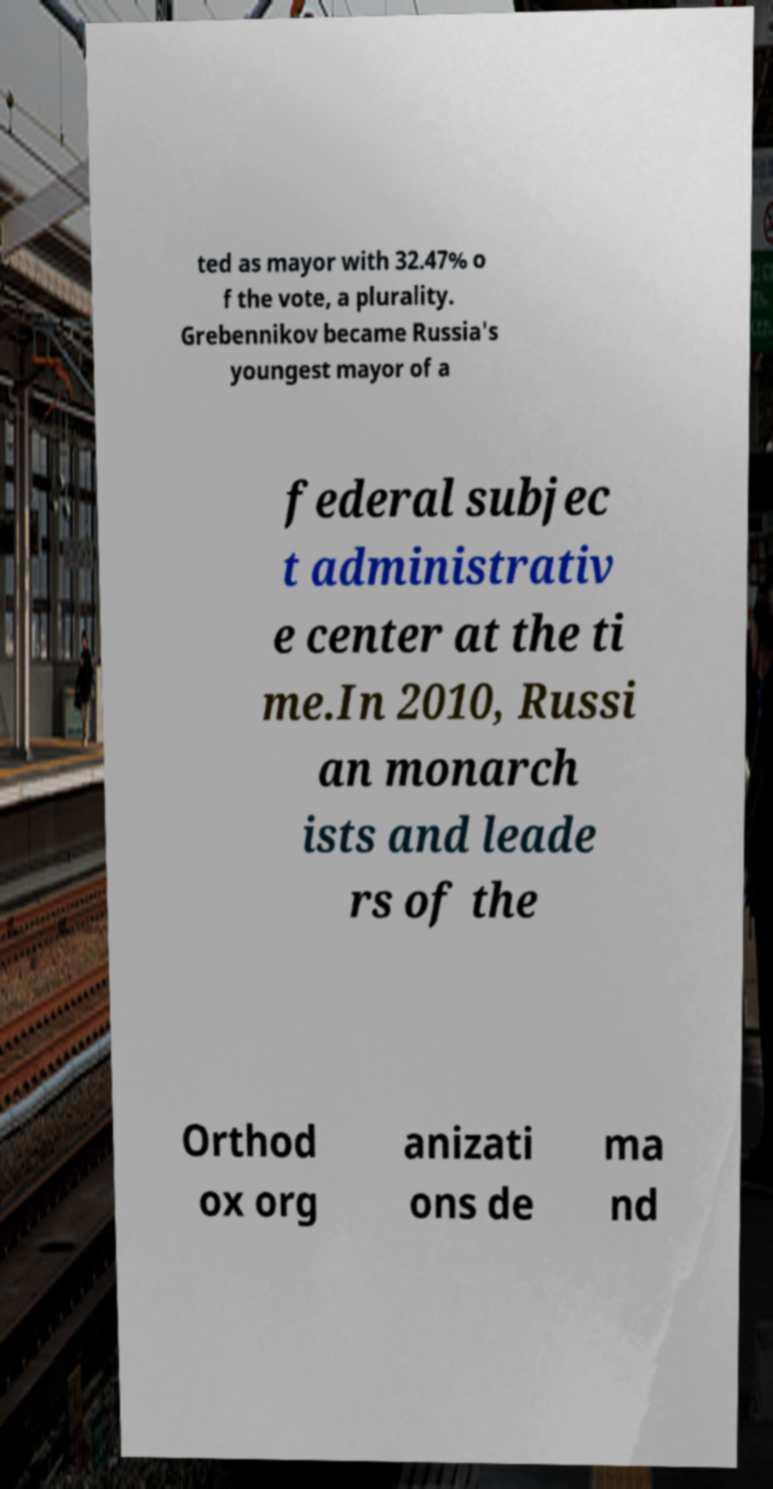Can you read and provide the text displayed in the image?This photo seems to have some interesting text. Can you extract and type it out for me? ted as mayor with 32.47% o f the vote, a plurality. Grebennikov became Russia's youngest mayor of a federal subjec t administrativ e center at the ti me.In 2010, Russi an monarch ists and leade rs of the Orthod ox org anizati ons de ma nd 